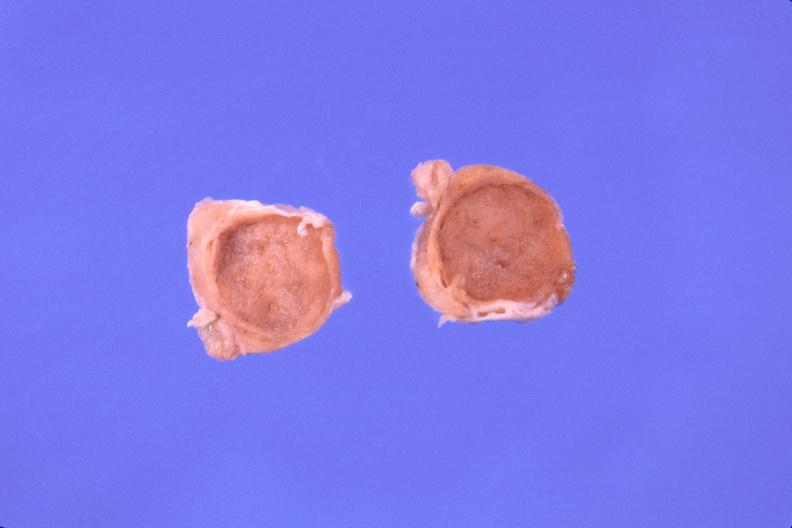what does this image show?
Answer the question using a single word or phrase. Pituitary 